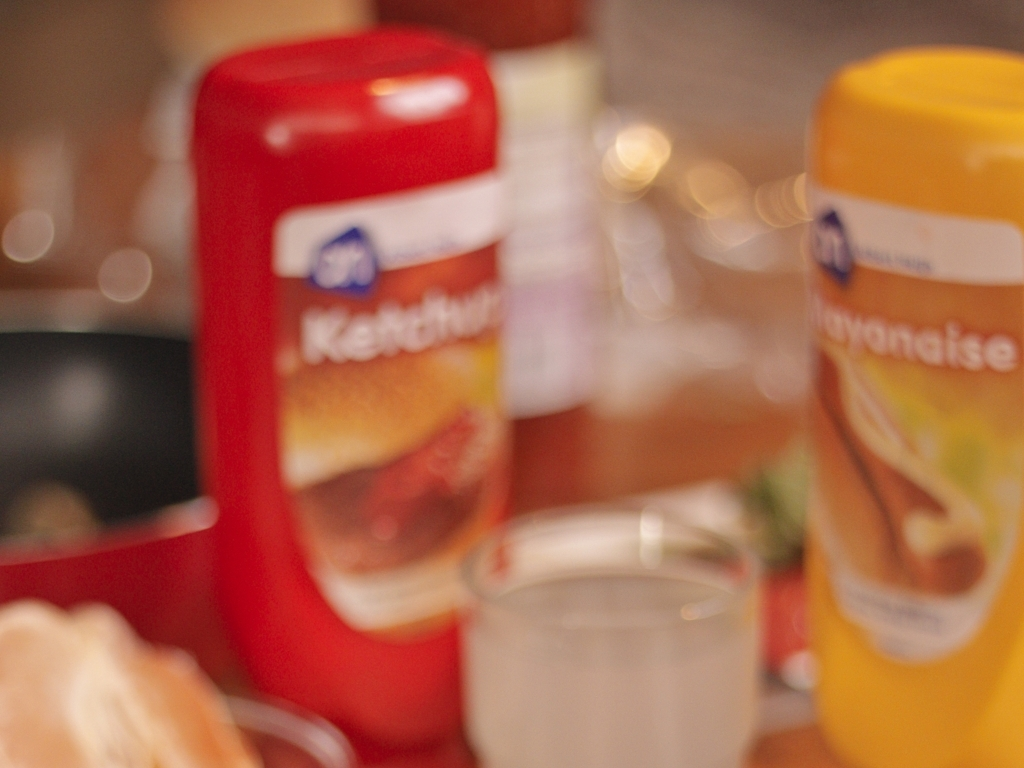What could be the reason for the blurriness in this image? The blurriness may result from a shallow depth of field, where only a small part of the image is in focus, or it could be due to movement during the photo capture, a low-quality camera lens, or an intentional stylistic choice. 